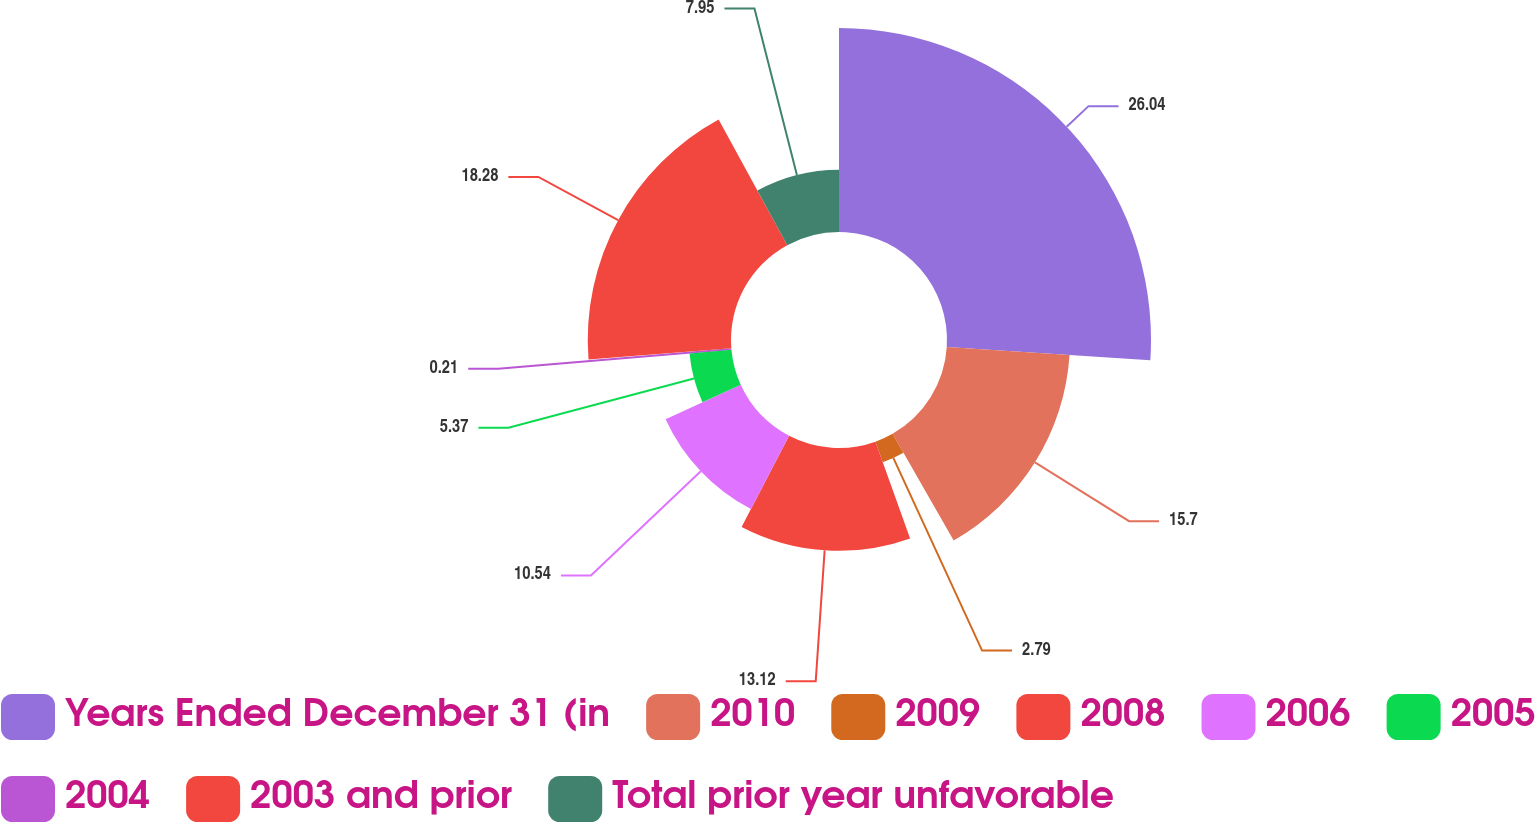<chart> <loc_0><loc_0><loc_500><loc_500><pie_chart><fcel>Years Ended December 31 (in<fcel>2010<fcel>2009<fcel>2008<fcel>2006<fcel>2005<fcel>2004<fcel>2003 and prior<fcel>Total prior year unfavorable<nl><fcel>26.03%<fcel>15.7%<fcel>2.79%<fcel>13.12%<fcel>10.54%<fcel>5.37%<fcel>0.21%<fcel>18.28%<fcel>7.95%<nl></chart> 